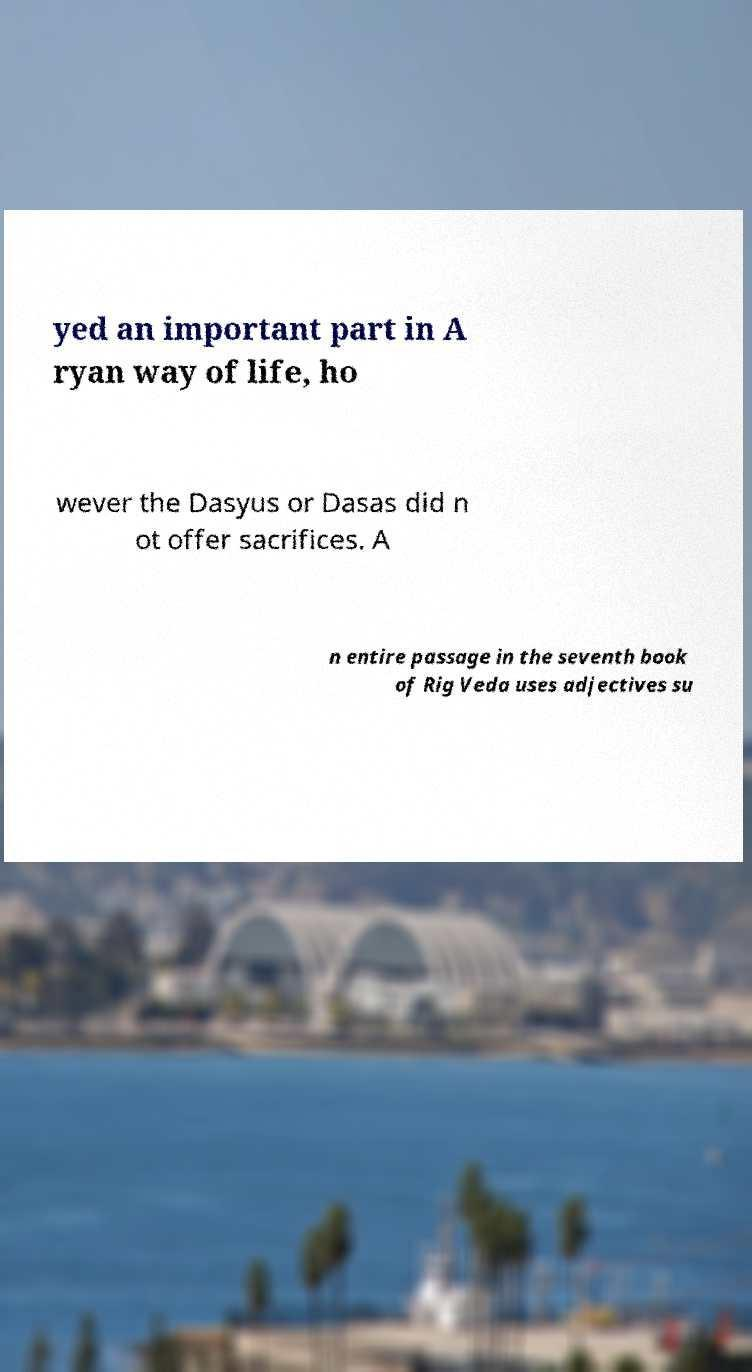Can you accurately transcribe the text from the provided image for me? yed an important part in A ryan way of life, ho wever the Dasyus or Dasas did n ot offer sacrifices. A n entire passage in the seventh book of Rig Veda uses adjectives su 